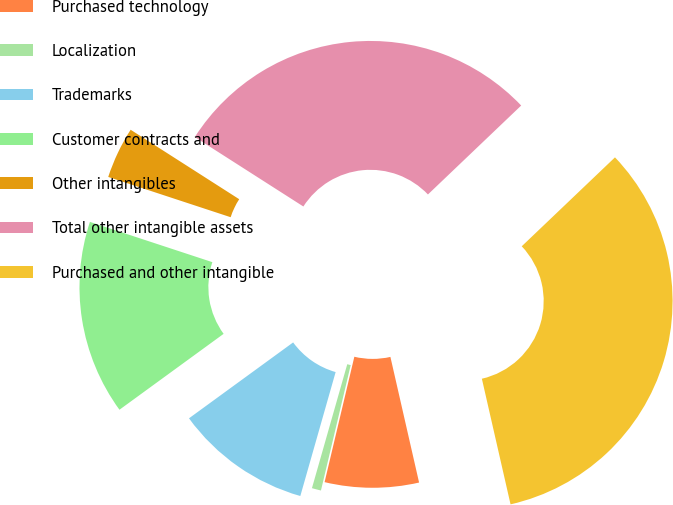Convert chart. <chart><loc_0><loc_0><loc_500><loc_500><pie_chart><fcel>Purchased technology<fcel>Localization<fcel>Trademarks<fcel>Customer contracts and<fcel>Other intangibles<fcel>Total other intangible assets<fcel>Purchased and other intangible<nl><fcel>7.28%<fcel>0.71%<fcel>10.56%<fcel>15.08%<fcel>4.0%<fcel>28.82%<fcel>33.55%<nl></chart> 